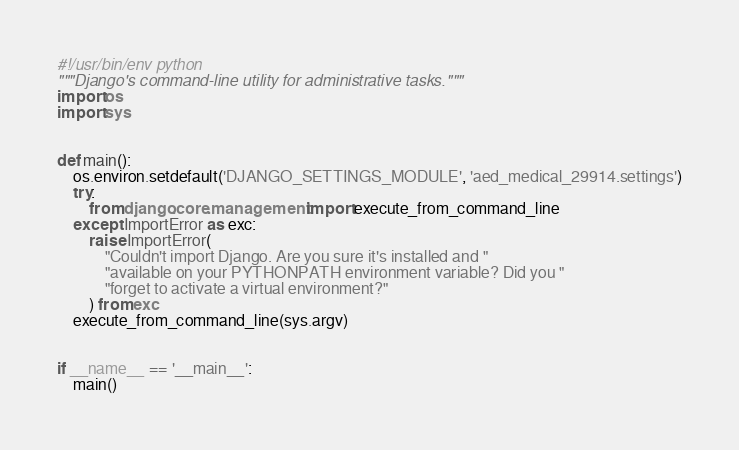Convert code to text. <code><loc_0><loc_0><loc_500><loc_500><_Python_>#!/usr/bin/env python
"""Django's command-line utility for administrative tasks."""
import os
import sys


def main():
    os.environ.setdefault('DJANGO_SETTINGS_MODULE', 'aed_medical_29914.settings')
    try:
        from django.core.management import execute_from_command_line
    except ImportError as exc:
        raise ImportError(
            "Couldn't import Django. Are you sure it's installed and "
            "available on your PYTHONPATH environment variable? Did you "
            "forget to activate a virtual environment?"
        ) from exc
    execute_from_command_line(sys.argv)


if __name__ == '__main__':
    main()
</code> 